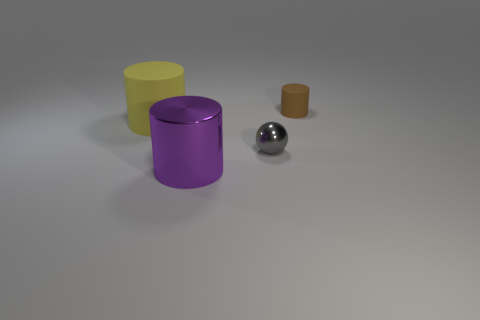Add 2 rubber cylinders. How many objects exist? 6 Subtract all balls. How many objects are left? 3 Add 4 balls. How many balls are left? 5 Add 2 big red blocks. How many big red blocks exist? 2 Subtract 1 yellow cylinders. How many objects are left? 3 Subtract all red metal cylinders. Subtract all large metal objects. How many objects are left? 3 